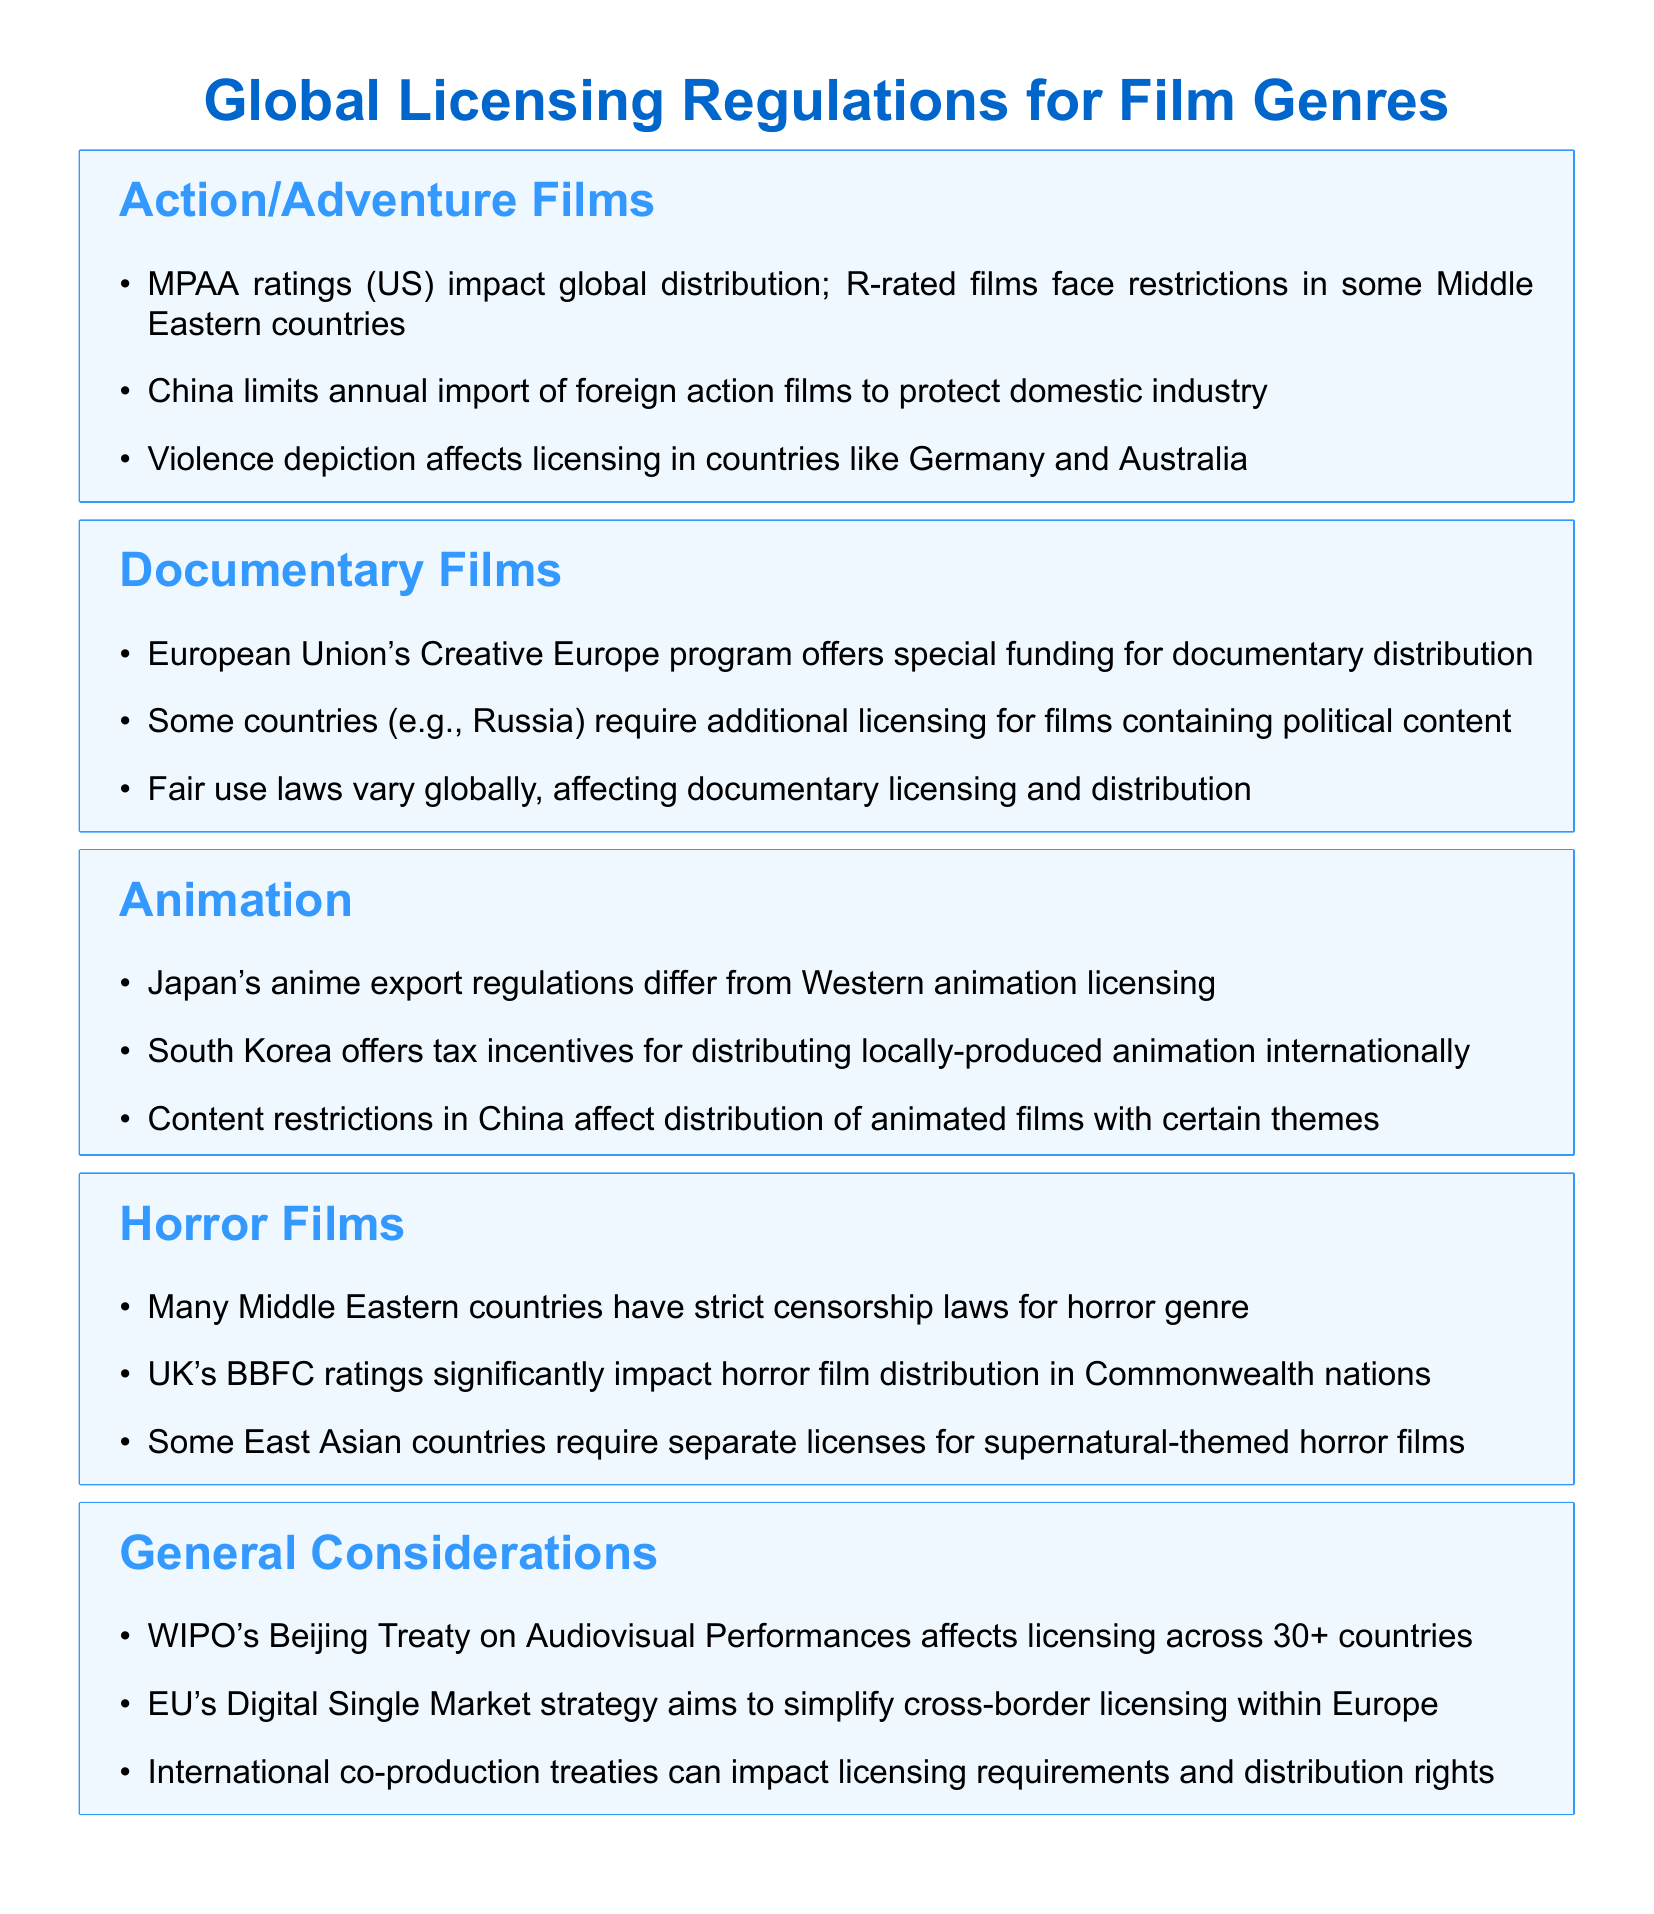What impacts global distribution of action films? The MPAA ratings (US) impact global distribution of action films as well as restrictions for R-rated films in some Middle Eastern countries.
Answer: MPAA ratings How many countries does WIPO's Beijing Treaty affect? WIPO's Beijing Treaty on Audiovisual Performances affects licensing across more than 30 countries.
Answer: 30+ What program offers special funding for documentary distribution? The European Union's Creative Europe program offers special funding for documentary distribution.
Answer: Creative Europe program What is a requirement for films containing political content in Russia? Some countries, including Russia, require additional licensing for films containing political content.
Answer: Additional licensing What do South Korea's incentives focus on? South Korea offers tax incentives for distributing locally-produced animation internationally.
Answer: Tax incentives Which country's BBFC ratings significantly impact horror film distribution? The UK's BBFC ratings significantly impact horror film distribution in Commonwealth nations.
Answer: UK What drives China's limits on foreign action film imports? China limits the annual import of foreign action films to protect its domestic industry.
Answer: Domestic industry What does the EU's Digital Single Market strategy aim to simplify? The EU's Digital Single Market strategy aims to simplify cross-border licensing within Europe.
Answer: Cross-border licensing 